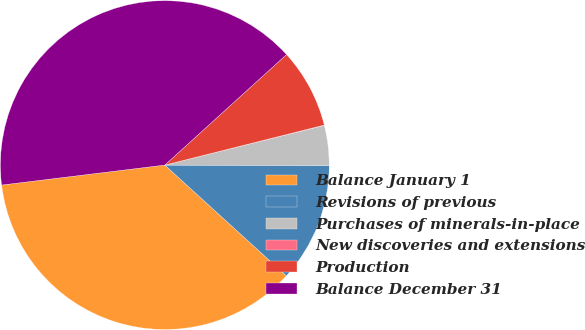<chart> <loc_0><loc_0><loc_500><loc_500><pie_chart><fcel>Balance January 1<fcel>Revisions of previous<fcel>Purchases of minerals-in-place<fcel>New discoveries and extensions<fcel>Production<fcel>Balance December 31<nl><fcel>36.3%<fcel>11.72%<fcel>3.92%<fcel>0.03%<fcel>7.82%<fcel>40.2%<nl></chart> 